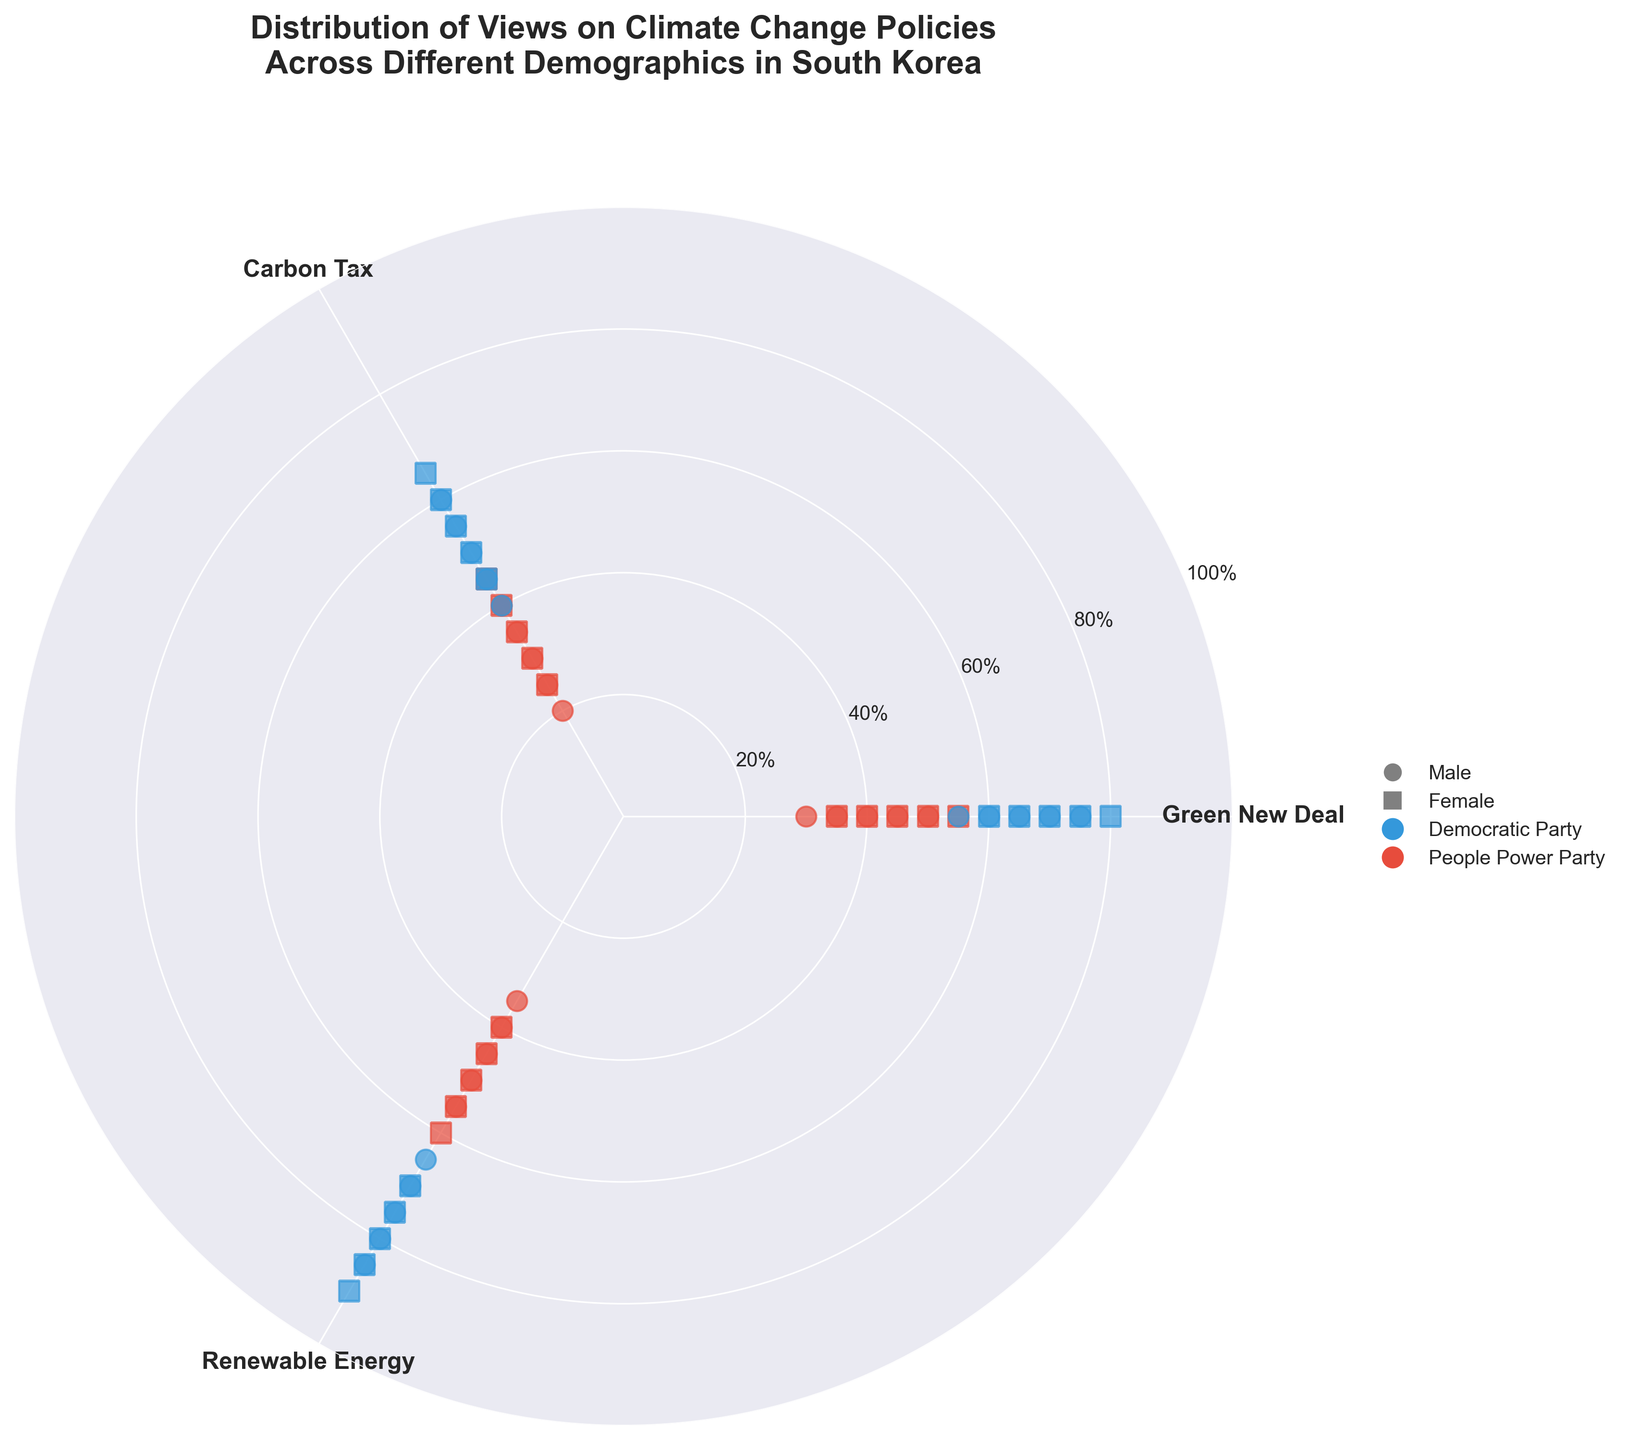What is the title of the figure? The title is usually located at the top of the chart and is written in bold text. In this case, it provides an overview of the chart's subject.
Answer: Distribution of Views on Climate Change Policies Across Different Demographics in South Korea How many axes are there on the polar scatter plot, and what do they represent? Polar scatter plots typically have a circular grid where radial and angular coordinates are used. Here, the radial lines represent support percentages, and the angles represent different climate change policies.
Answer: Three axes representing Green New Deal, Carbon Tax, and Renewable Energy Investment Which political party shows higher support for the Green New Deal among the 18-29 age group? By observing the color-coded points for the 18-29 age group, the Democratic Party is represented by blue, and the People Power Party by red.
Answer: Democratic Party Which demographic group shows the lowest support for the Carbon Tax? Examine the radial positions associated with the Carbon Tax axis and identify the group with the smallest radial distance from the center. This lowest support will be indicated by the closest position to the center.
Answer: Males aged 60+ from the People Power Party Among females aged 30-39, which political affiliation shows higher support for Renewable Energy Investment? Identify the color-coded points for females aged 30-39, then compare the heights (radial distances) on the Renewable Energy Investment axis.
Answer: Democratic Party Compare male supporters of the Democratic Party aged 18-29 and 40-49. Which policy shows the biggest change in support between these age groups? Locate the radial positions for both male groups in the support categories. Calculate the difference for each policy and identify the policy with the largest gap.
Answer: Green New Deal What is the average support for Renewable Energy Investment among females in the Democratic Party across all age groups? Identify and sum the support percentages for Renewable Energy Investment for females in the Democratic Party, then divide by the number of data points.
Answer: 80% Which gender has higher variability in support for the Carbon Tax within the People Power Party? Compare the spread of the radial positions for males and females in the People Power Party on the Carbon Tax axis. More spread indicates higher variability.
Answer: Males Do males or females aged 50-59 in the People Power Party show higher average support across all three policies? Calculate the average support across the three policies for both males and females aged 50-59 in the People Power Party, then compare these averages.
Answer: Females Which age group shows the largest spread in support percentages for the Democratic Party across the three policies? Evaluate the radial distances of the points for each age group in the Democratic Party. The largest spread will have the widest range of radial distances.
Answer: 18-29 